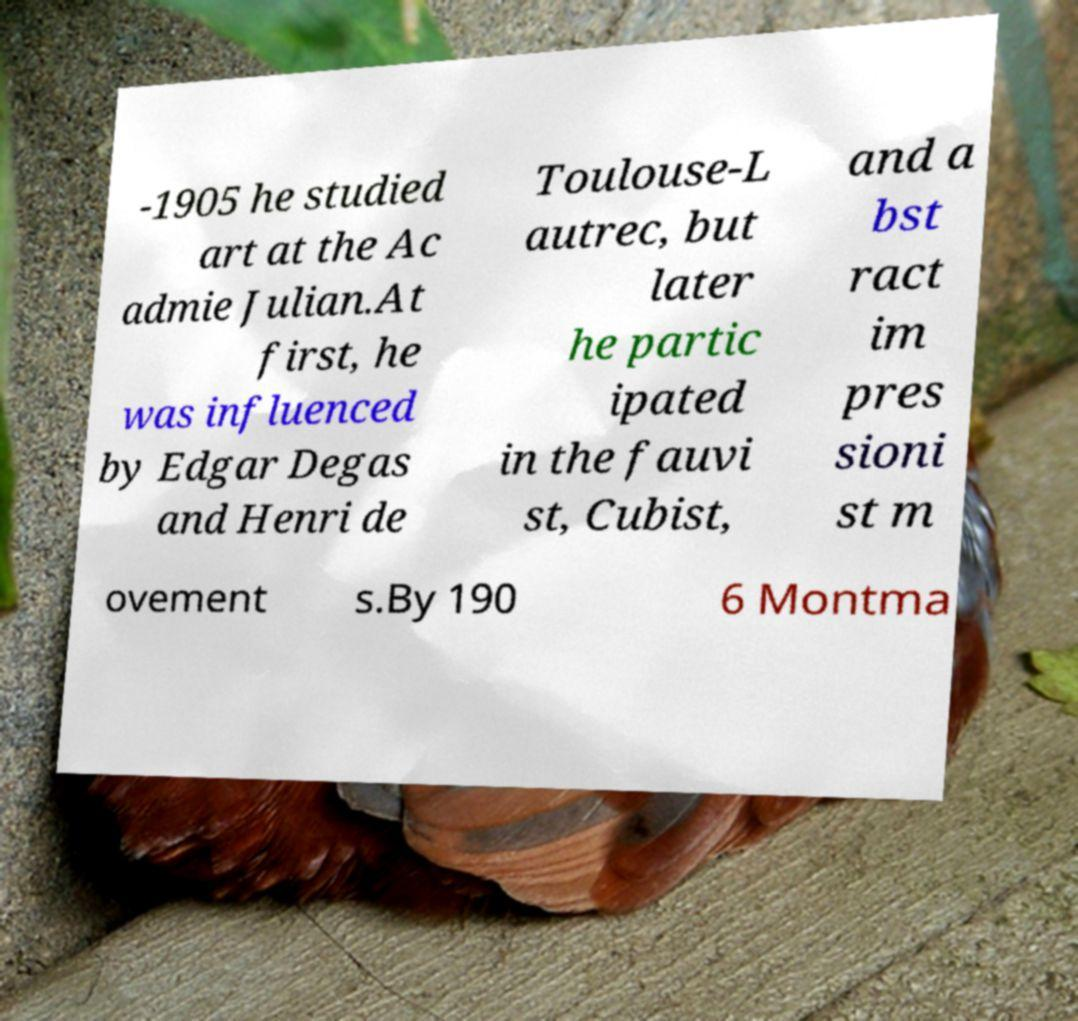There's text embedded in this image that I need extracted. Can you transcribe it verbatim? -1905 he studied art at the Ac admie Julian.At first, he was influenced by Edgar Degas and Henri de Toulouse-L autrec, but later he partic ipated in the fauvi st, Cubist, and a bst ract im pres sioni st m ovement s.By 190 6 Montma 